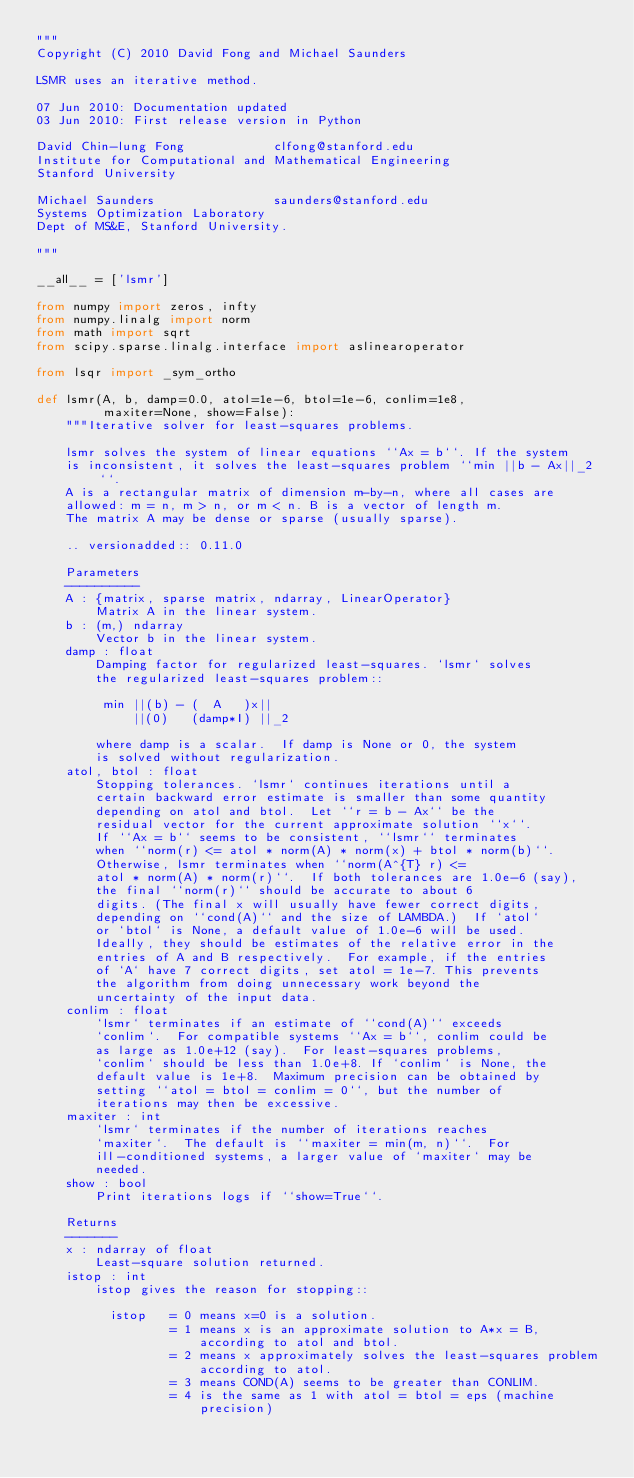Convert code to text. <code><loc_0><loc_0><loc_500><loc_500><_Python_>"""
Copyright (C) 2010 David Fong and Michael Saunders

LSMR uses an iterative method.

07 Jun 2010: Documentation updated
03 Jun 2010: First release version in Python

David Chin-lung Fong            clfong@stanford.edu
Institute for Computational and Mathematical Engineering
Stanford University

Michael Saunders                saunders@stanford.edu
Systems Optimization Laboratory
Dept of MS&E, Stanford University.

"""

__all__ = ['lsmr']

from numpy import zeros, infty
from numpy.linalg import norm
from math import sqrt
from scipy.sparse.linalg.interface import aslinearoperator

from lsqr import _sym_ortho

def lsmr(A, b, damp=0.0, atol=1e-6, btol=1e-6, conlim=1e8,
         maxiter=None, show=False):
    """Iterative solver for least-squares problems.

    lsmr solves the system of linear equations ``Ax = b``. If the system
    is inconsistent, it solves the least-squares problem ``min ||b - Ax||_2``.
    A is a rectangular matrix of dimension m-by-n, where all cases are
    allowed: m = n, m > n, or m < n. B is a vector of length m.
    The matrix A may be dense or sparse (usually sparse).

    .. versionadded:: 0.11.0

    Parameters
    ----------
    A : {matrix, sparse matrix, ndarray, LinearOperator}
        Matrix A in the linear system.
    b : (m,) ndarray
        Vector b in the linear system.
    damp : float
        Damping factor for regularized least-squares. `lsmr` solves
        the regularized least-squares problem::

         min ||(b) - (  A   )x||
             ||(0)   (damp*I) ||_2

        where damp is a scalar.  If damp is None or 0, the system
        is solved without regularization.
    atol, btol : float
        Stopping tolerances. `lsmr` continues iterations until a
        certain backward error estimate is smaller than some quantity
        depending on atol and btol.  Let ``r = b - Ax`` be the
        residual vector for the current approximate solution ``x``.
        If ``Ax = b`` seems to be consistent, ``lsmr`` terminates
        when ``norm(r) <= atol * norm(A) * norm(x) + btol * norm(b)``.
        Otherwise, lsmr terminates when ``norm(A^{T} r) <=
        atol * norm(A) * norm(r)``.  If both tolerances are 1.0e-6 (say),
        the final ``norm(r)`` should be accurate to about 6
        digits. (The final x will usually have fewer correct digits,
        depending on ``cond(A)`` and the size of LAMBDA.)  If `atol`
        or `btol` is None, a default value of 1.0e-6 will be used.
        Ideally, they should be estimates of the relative error in the
        entries of A and B respectively.  For example, if the entries
        of `A` have 7 correct digits, set atol = 1e-7. This prevents
        the algorithm from doing unnecessary work beyond the
        uncertainty of the input data.
    conlim : float
        `lsmr` terminates if an estimate of ``cond(A)`` exceeds
        `conlim`.  For compatible systems ``Ax = b``, conlim could be
        as large as 1.0e+12 (say).  For least-squares problems,
        `conlim` should be less than 1.0e+8. If `conlim` is None, the
        default value is 1e+8.  Maximum precision can be obtained by
        setting ``atol = btol = conlim = 0``, but the number of
        iterations may then be excessive.
    maxiter : int
        `lsmr` terminates if the number of iterations reaches
        `maxiter`.  The default is ``maxiter = min(m, n)``.  For
        ill-conditioned systems, a larger value of `maxiter` may be
        needed.
    show : bool
        Print iterations logs if ``show=True``.

    Returns
    -------
    x : ndarray of float
        Least-square solution returned.
    istop : int
        istop gives the reason for stopping::

          istop   = 0 means x=0 is a solution.
                  = 1 means x is an approximate solution to A*x = B,
                      according to atol and btol.
                  = 2 means x approximately solves the least-squares problem
                      according to atol.
                  = 3 means COND(A) seems to be greater than CONLIM.
                  = 4 is the same as 1 with atol = btol = eps (machine
                      precision)</code> 